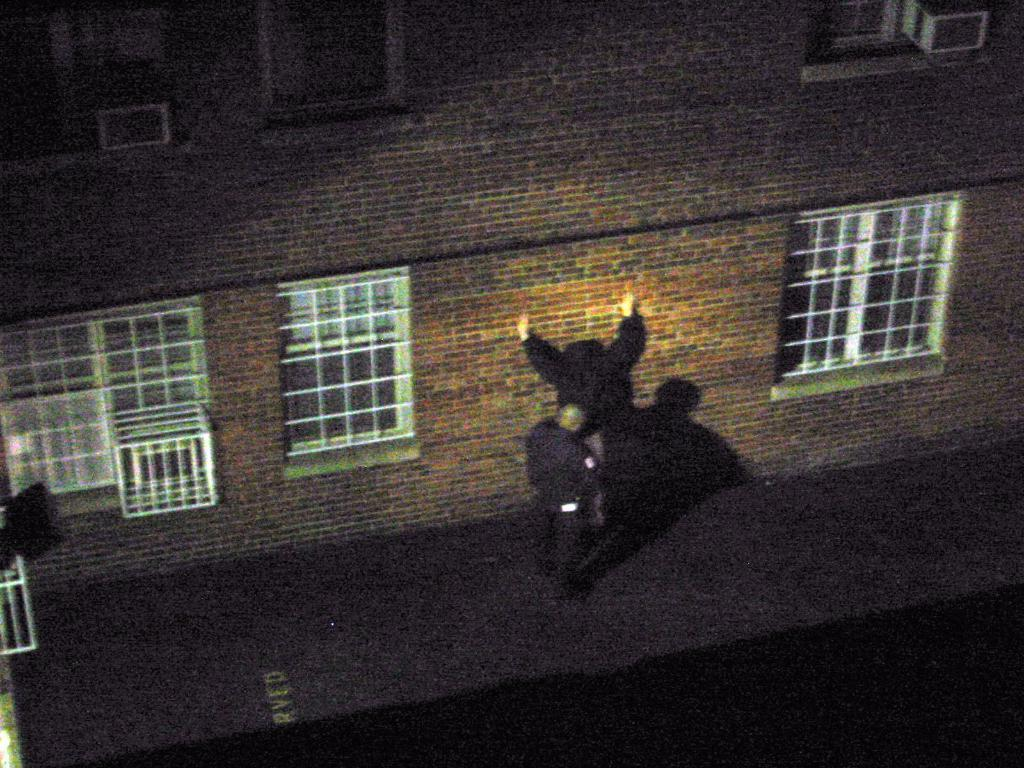What is the main subject of the image? There is a person standing in the image. What can be seen in the background of the image? There is a building in the image. Are there any specific features of the building visible? Yes, there are windows visible in the image. What else can be observed in the image? The shadow of a person is present on a wall in the image. What type of drug is the person holding in their pocket in the image? There is no indication in the image that the person is holding any drug, nor is there any mention of a pocket. 